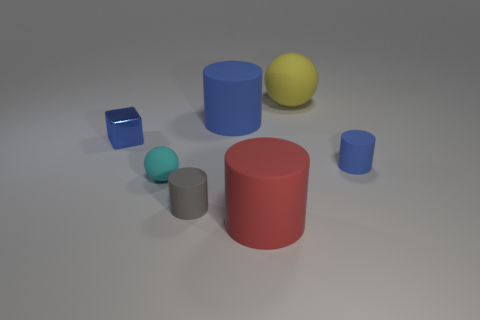What number of small things are either blue cubes or blue things?
Provide a short and direct response. 2. There is a small rubber cylinder in front of the tiny ball; does it have the same color as the large object that is in front of the tiny cyan rubber object?
Offer a terse response. No. What number of other objects are the same color as the small block?
Provide a short and direct response. 2. What number of yellow objects are tiny cubes or large things?
Offer a terse response. 1. There is a small metallic thing; is its shape the same as the large object in front of the tiny gray cylinder?
Your answer should be very brief. No. What shape is the gray object?
Keep it short and to the point. Cylinder. What is the material of the blue cylinder that is the same size as the cyan object?
Your answer should be compact. Rubber. Is there anything else that has the same size as the red rubber cylinder?
Your answer should be very brief. Yes. How many objects are either large yellow matte balls or things behind the big blue thing?
Your answer should be compact. 1. What size is the cyan object that is the same material as the yellow thing?
Your answer should be very brief. Small. 